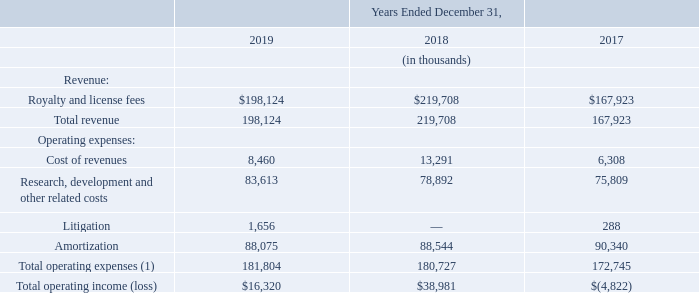Product Licensing Segment
(1) Excludes operating expenses which are not allocated on a segment basis.
Product Licensing revenue for the year ended December 31, 2019 was $198.1 million as compared to $219.7 million for the year ended December 31, 2018, a decrease of $21.6 million. The decrease in revenue was primarily due to the timing and duration of minimum guarantee contracts up for renewal and executed, decreased NRE services revenue, as well as a decrease in per-unit royalty revenue in 2019 as compared to 2018.
Why was Product Licensing revenue decreased in 2019 compared to 2018? The timing and duration of minimum guarantee contracts up for renewal and executed, decreased nre services revenue, as well as a decrease in per-unit royalty revenue. What was the total operating income/loss from 2017 to 2019, respectively?
Answer scale should be: thousand. $(4,822), $38,981, $16,320. What were the litigation costs in 2017 and 2019, respectively?
Answer scale should be: thousand. 288, 1,656. What is the overall proportion of litigation and amortization expense over the total operating expense in 2019? (1,656+88,075)/181,804 
Answer: 0.49. What is the percentage change in total revenue in 2019 compared to 2018?
Answer scale should be: percent. (198,124-219,708)/219,708 
Answer: -9.82. What is the average total operating expense from 2017 to 2019?
Answer scale should be: thousand. (172,745+180,727+181,804)/3 
Answer: 178425.33. 